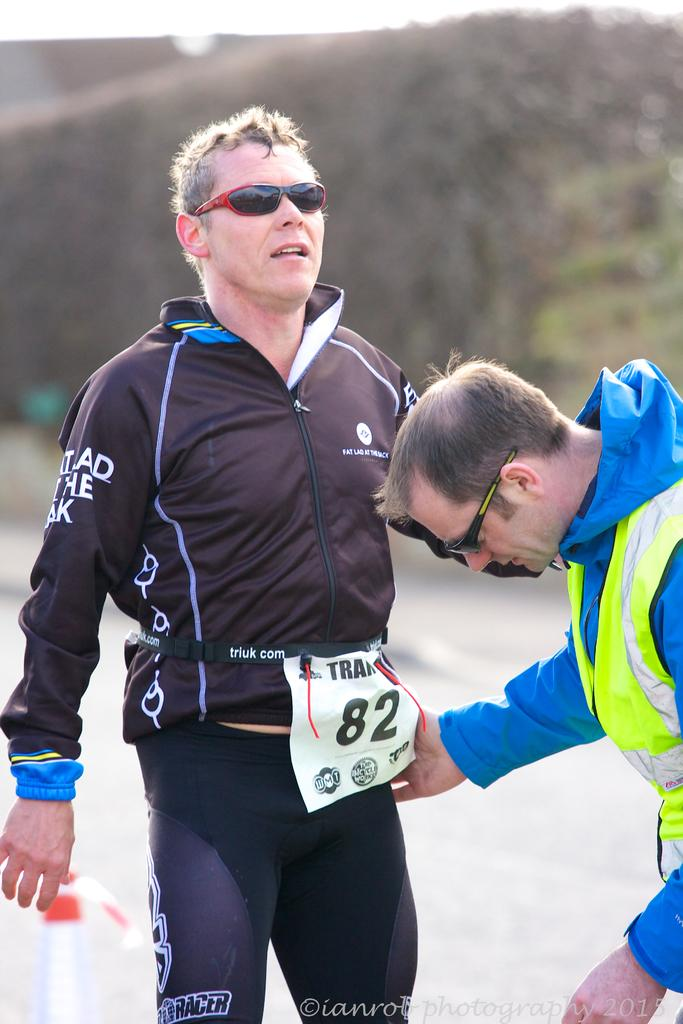Provide a one-sentence caption for the provided image. a couple men, one of which wears the number 82. 